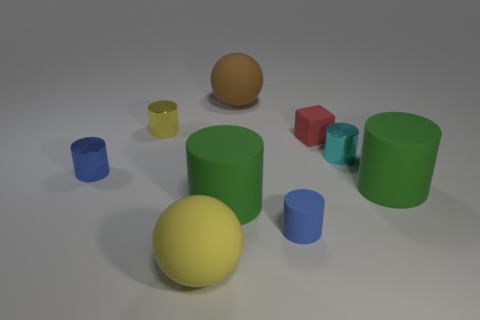There is a large rubber sphere in front of the blue metal object; is its color the same as the cube?
Offer a terse response. No. How many rubber cylinders are behind the large cylinder that is on the left side of the blue matte cylinder?
Offer a very short reply. 1. The other matte thing that is the same size as the blue matte object is what color?
Provide a succinct answer. Red. What material is the cylinder that is left of the yellow cylinder?
Make the answer very short. Metal. What is the small object that is to the left of the large yellow rubber thing and behind the blue metallic cylinder made of?
Your answer should be very brief. Metal. Do the metal thing to the right of the yellow sphere and the tiny blue metallic thing have the same size?
Provide a short and direct response. Yes. The brown object is what shape?
Provide a succinct answer. Sphere. How many other matte objects are the same shape as the small red thing?
Make the answer very short. 0. How many tiny objects are behind the cyan shiny object and to the right of the small blue rubber thing?
Provide a succinct answer. 1. The tiny rubber cylinder has what color?
Ensure brevity in your answer.  Blue. 